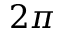Convert formula to latex. <formula><loc_0><loc_0><loc_500><loc_500>2 \pi</formula> 